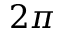Convert formula to latex. <formula><loc_0><loc_0><loc_500><loc_500>2 \pi</formula> 